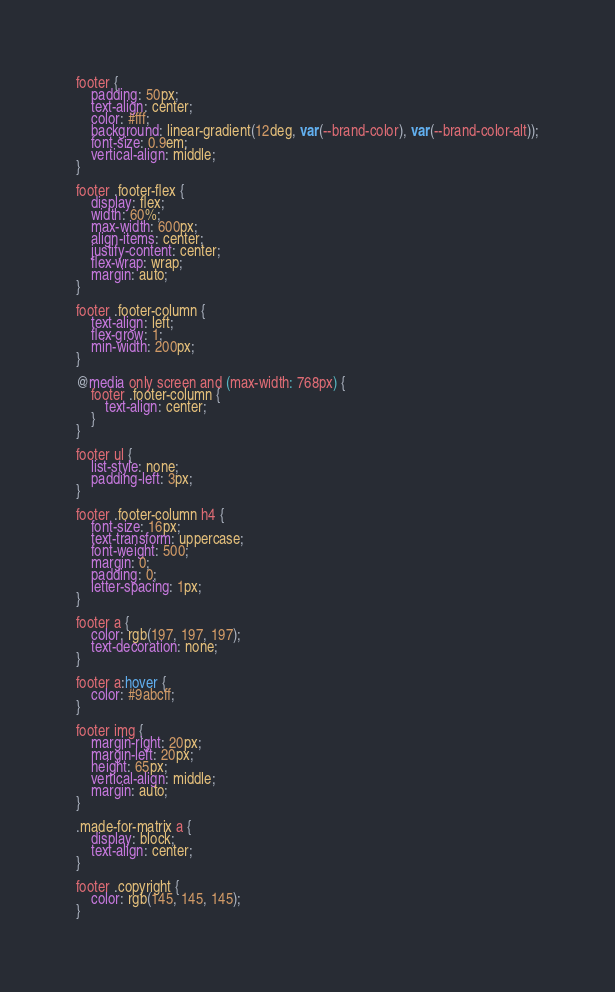Convert code to text. <code><loc_0><loc_0><loc_500><loc_500><_CSS_>footer {
	padding: 50px;
	text-align: center;
	color: #fff;
	background: linear-gradient(12deg, var(--brand-color), var(--brand-color-alt));
	font-size: 0.9em;
    vertical-align: middle;
}

footer .footer-flex {
    display: flex;
    width: 60%;
    max-width: 600px;
    align-items: center;
    justify-content: center;
    flex-wrap: wrap;
    margin: auto;
}

footer .footer-column {
    text-align: left;
    flex-grow: 1;
    min-width: 200px;
}

@media only screen and (max-width: 768px) {
    footer .footer-column {
        text-align: center;
    }
}

footer ul {
    list-style: none;
    padding-left: 3px;
}

footer .footer-column h4 {
    font-size: 16px;
    text-transform: uppercase;
    font-weight: 500;
    margin: 0;
    padding: 0;
    letter-spacing: 1px;
}

footer a {
    color: rgb(197, 197, 197);
	text-decoration: none;
}

footer a:hover {
    color: #9abcff;
}

footer img {
	margin-right: 20px;
	margin-left: 20px;
	height: 65px;
    vertical-align: middle;
    margin: auto;
}

.made-for-matrix a {
    display: block;
    text-align: center;
}

footer .copyright {
    color: rgb(145, 145, 145);
}
</code> 